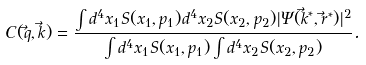Convert formula to latex. <formula><loc_0><loc_0><loc_500><loc_500>C ( { \vec { q } } , { \vec { k } } ) = \frac { \int d ^ { 4 } x _ { 1 } S ( x _ { 1 } , p _ { 1 } ) d ^ { 4 } x _ { 2 } S ( x _ { 2 } , p _ { 2 } ) | \Psi ( { \vec { k } } ^ { * } , { \vec { r } } ^ { * } ) | ^ { 2 } } { \int d ^ { 4 } x _ { 1 } S ( x _ { 1 } , p _ { 1 } ) \int d ^ { 4 } x _ { 2 } S ( x _ { 2 } , p _ { 2 } ) } .</formula> 